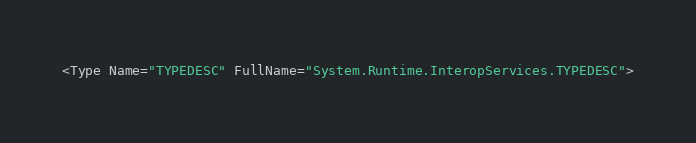Convert code to text. <code><loc_0><loc_0><loc_500><loc_500><_XML_><Type Name="TYPEDESC" FullName="System.Runtime.InteropServices.TYPEDESC"></code> 